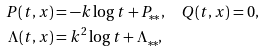Convert formula to latex. <formula><loc_0><loc_0><loc_500><loc_500>P ( t , x ) & = - k \log t + P _ { * * } , \quad Q ( t , x ) = 0 , \\ \Lambda ( t , x ) & = k ^ { 2 } \log t + \Lambda _ { * * } ,</formula> 